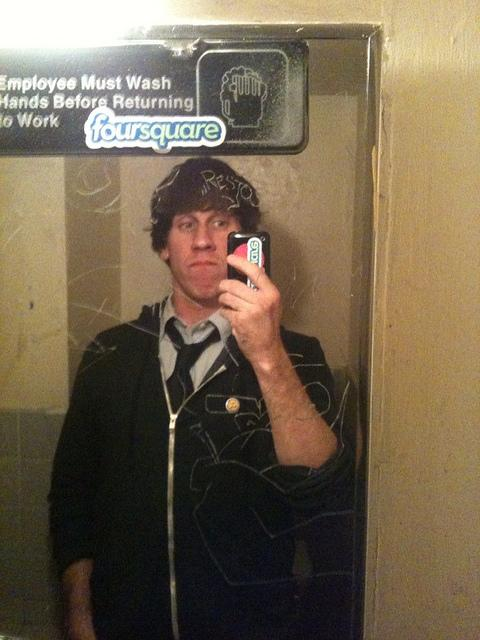Who is taking this man's picture? himself 